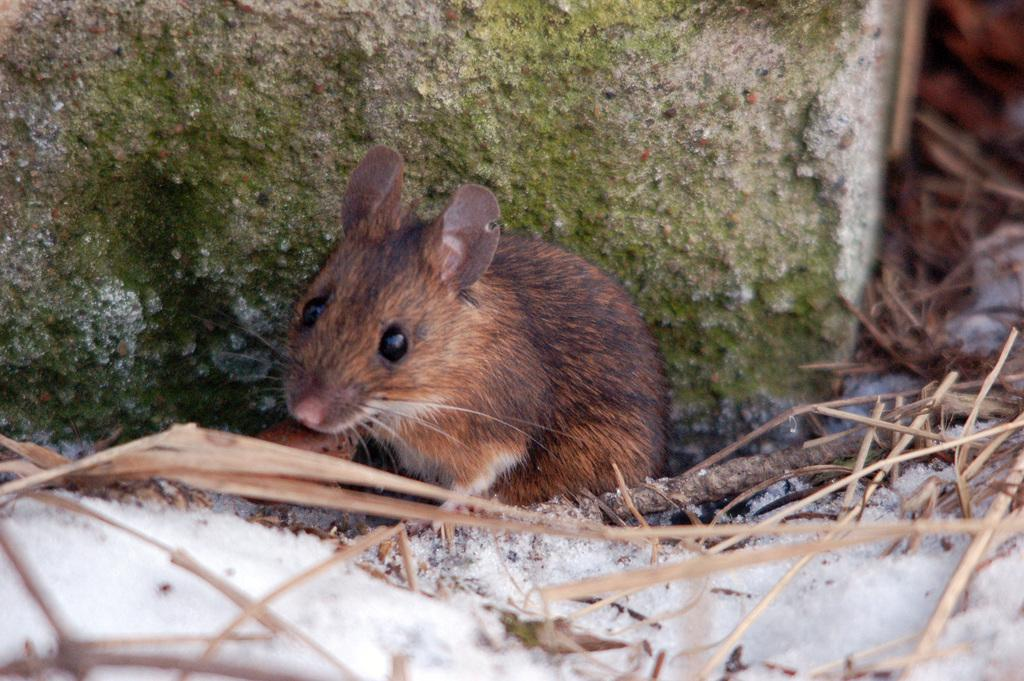What type of animal is in the image? There is a rat in the image. What color is the rat? The rat is brown in color. What else can be seen in the image besides the rat? There are sticks visible in the image. What colors are present on the wall in the background? The wall in the background is green and cream in color. How much does the dog cost in the image? There is no dog present in the image, so it is not possible to determine its cost. 